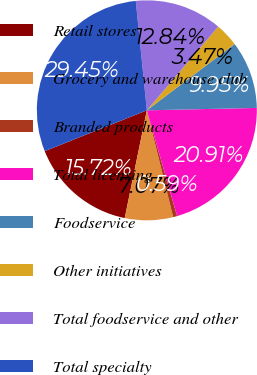<chart> <loc_0><loc_0><loc_500><loc_500><pie_chart><fcel>Retail stores<fcel>Grocery and warehouse club<fcel>Branded products<fcel>Total licensing<fcel>Foodservice<fcel>Other initiatives<fcel>Total foodservice and other<fcel>Total specialty<nl><fcel>15.72%<fcel>7.07%<fcel>0.59%<fcel>20.91%<fcel>9.95%<fcel>3.47%<fcel>12.84%<fcel>29.45%<nl></chart> 